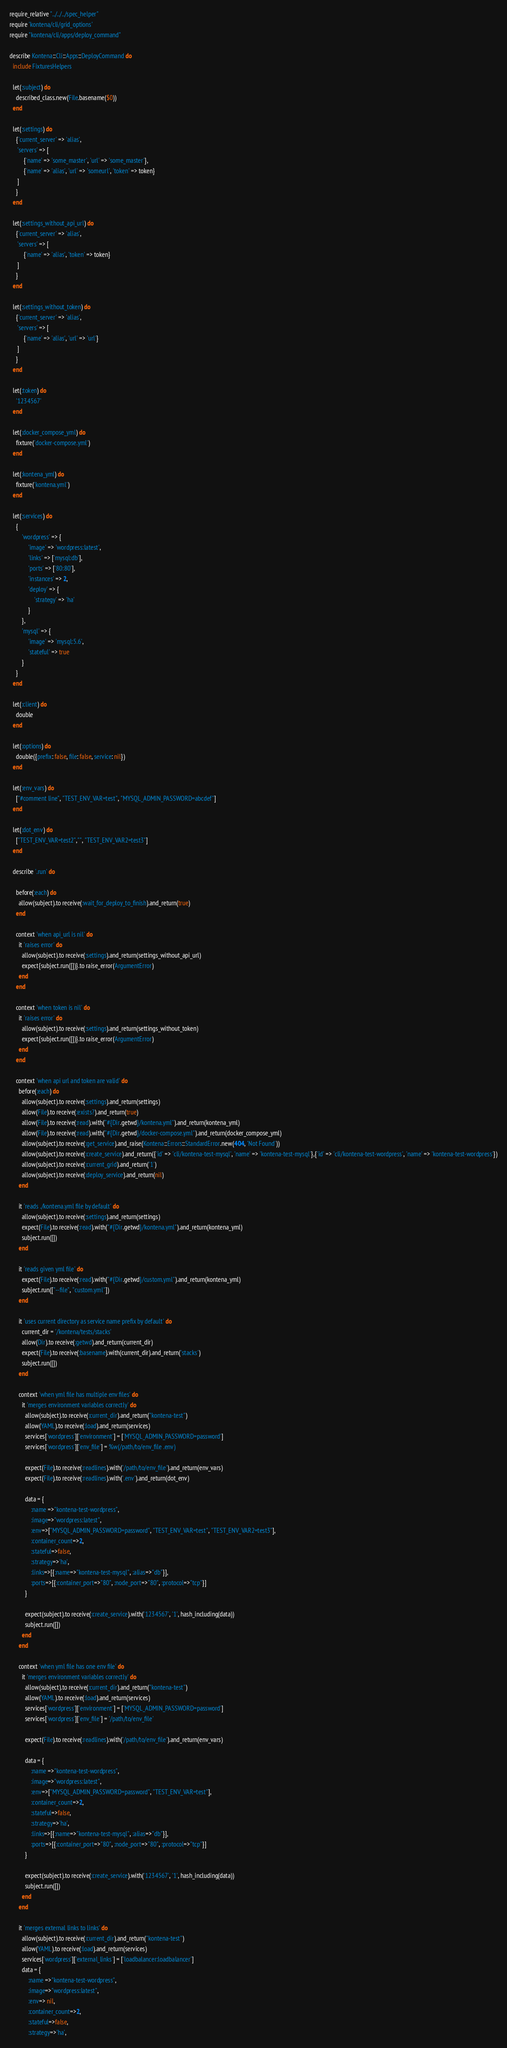Convert code to text. <code><loc_0><loc_0><loc_500><loc_500><_Ruby_>require_relative "../../../spec_helper"
require 'kontena/cli/grid_options'
require "kontena/cli/apps/deploy_command"

describe Kontena::Cli::Apps::DeployCommand do
  include FixturesHelpers

  let(:subject) do
    described_class.new(File.basename($0))
  end

  let(:settings) do
    {'current_server' => 'alias',
     'servers' => [
         {'name' => 'some_master', 'url' => 'some_master'},
         {'name' => 'alias', 'url' => 'someurl', 'token' => token}
     ]
    }
  end

  let(:settings_without_api_url) do
    {'current_server' => 'alias',
     'servers' => [
         {'name' => 'alias', 'token' => token}
     ]
    }
  end

  let(:settings_without_token) do
    {'current_server' => 'alias',
     'servers' => [
         {'name' => 'alias', 'url' => 'url'}
     ]
    }
  end

  let(:token) do
    '1234567'
  end

  let(:docker_compose_yml) do
    fixture('docker-compose.yml')
  end

  let(:kontena_yml) do
    fixture('kontena.yml')
  end

  let(:services) do
    {
        'wordpress' => {
            'image' => 'wordpress:latest',
            'links' => ['mysql:db'],
            'ports' => ['80:80'],
            'instances' => 2,
            'deploy' => {
                'strategy' => 'ha'
            }
        },
        'mysql' => {
            'image' => 'mysql:5.6',
            'stateful' => true
        }
    }
  end

  let(:client) do
    double
  end

  let(:options) do
    double({prefix: false, file: false, service: nil})
  end

  let(:env_vars) do
    ["#comment line", "TEST_ENV_VAR=test", "MYSQL_ADMIN_PASSWORD=abcdef"]
  end

  let(:dot_env) do
    ["TEST_ENV_VAR=test2","", "TEST_ENV_VAR2=test3"]
  end

  describe '.run' do

    before(:each) do
      allow(subject).to receive(:wait_for_deploy_to_finish).and_return(true)
    end

    context 'when api_url is nil' do
      it 'raises error' do
        allow(subject).to receive(:settings).and_return(settings_without_api_url)
        expect{subject.run([])}.to raise_error(ArgumentError)
      end
    end

    context 'when token is nil' do
      it 'raises error' do
        allow(subject).to receive(:settings).and_return(settings_without_token)
        expect{subject.run([])}.to raise_error(ArgumentError)
      end
    end

    context 'when api url and token are valid' do
      before(:each) do
        allow(subject).to receive(:settings).and_return(settings)
        allow(File).to receive(:exists?).and_return(true)
        allow(File).to receive(:read).with("#{Dir.getwd}/kontena.yml").and_return(kontena_yml)
        allow(File).to receive(:read).with("#{Dir.getwd}/docker-compose.yml").and_return(docker_compose_yml)
        allow(subject).to receive(:get_service).and_raise(Kontena::Errors::StandardError.new(404, 'Not Found'))
        allow(subject).to receive(:create_service).and_return({'id' => 'cli/kontena-test-mysql', 'name' => 'kontena-test-mysql'},{'id' => 'cli/kontena-test-wordpress', 'name' => 'kontena-test-wordpress'})
        allow(subject).to receive(:current_grid).and_return('1')
        allow(subject).to receive(:deploy_service).and_return(nil)
      end

      it 'reads ./kontena.yml file by default' do
        allow(subject).to receive(:settings).and_return(settings)
        expect(File).to receive(:read).with("#{Dir.getwd}/kontena.yml").and_return(kontena_yml)
        subject.run([])
      end

      it 'reads given yml file' do
        expect(File).to receive(:read).with("#{Dir.getwd}/custom.yml").and_return(kontena_yml)
        subject.run(["--file", "custom.yml"])
      end

      it 'uses current directory as service name prefix by default' do
        current_dir = '/kontena/tests/stacks'
        allow(Dir).to receive(:getwd).and_return(current_dir)
        expect(File).to receive(:basename).with(current_dir).and_return('stacks')
        subject.run([])
      end

      context 'when yml file has multiple env files' do
        it 'merges environment variables correctly' do
          allow(subject).to receive(:current_dir).and_return("kontena-test")
          allow(YAML).to receive(:load).and_return(services)
          services['wordpress']['environment'] = ['MYSQL_ADMIN_PASSWORD=password']
          services['wordpress']['env_file'] = %w(/path/to/env_file .env)

          expect(File).to receive(:readlines).with('/path/to/env_file').and_return(env_vars)
          expect(File).to receive(:readlines).with('.env').and_return(dot_env)

          data = {
              :name =>"kontena-test-wordpress",
              :image=>"wordpress:latest",
              :env=>["MYSQL_ADMIN_PASSWORD=password", "TEST_ENV_VAR=test", "TEST_ENV_VAR2=test3"],
              :container_count=>2,
              :stateful=>false,
              :strategy=>'ha',
              :links=>[{:name=>"kontena-test-mysql", :alias=>"db"}],
              :ports=>[{:container_port=>"80", :node_port=>"80", :protocol=>"tcp"}]
          }

          expect(subject).to receive(:create_service).with('1234567', '1', hash_including(data))
          subject.run([])
        end
      end

      context 'when yml file has one env file' do
        it 'merges environment variables correctly' do
          allow(subject).to receive(:current_dir).and_return("kontena-test")
          allow(YAML).to receive(:load).and_return(services)
          services['wordpress']['environment'] = ['MYSQL_ADMIN_PASSWORD=password']
          services['wordpress']['env_file'] = '/path/to/env_file'

          expect(File).to receive(:readlines).with('/path/to/env_file').and_return(env_vars)

          data = {
              :name =>"kontena-test-wordpress",
              :image=>"wordpress:latest",
              :env=>["MYSQL_ADMIN_PASSWORD=password", "TEST_ENV_VAR=test"],
              :container_count=>2,
              :stateful=>false,
              :strategy=>'ha',
              :links=>[{:name=>"kontena-test-mysql", :alias=>"db"}],
              :ports=>[{:container_port=>"80", :node_port=>"80", :protocol=>"tcp"}]
          }

          expect(subject).to receive(:create_service).with('1234567', '1', hash_including(data))
          subject.run([])
        end
      end

      it 'merges external links to links' do
        allow(subject).to receive(:current_dir).and_return("kontena-test")
        allow(YAML).to receive(:load).and_return(services)
        services['wordpress']['external_links'] = ['loadbalancer:loadbalancer']
        data = {
            :name =>"kontena-test-wordpress",
            :image=>"wordpress:latest",
            :env=> nil,
            :container_count=>2,
            :stateful=>false,
            :strategy=>'ha',</code> 